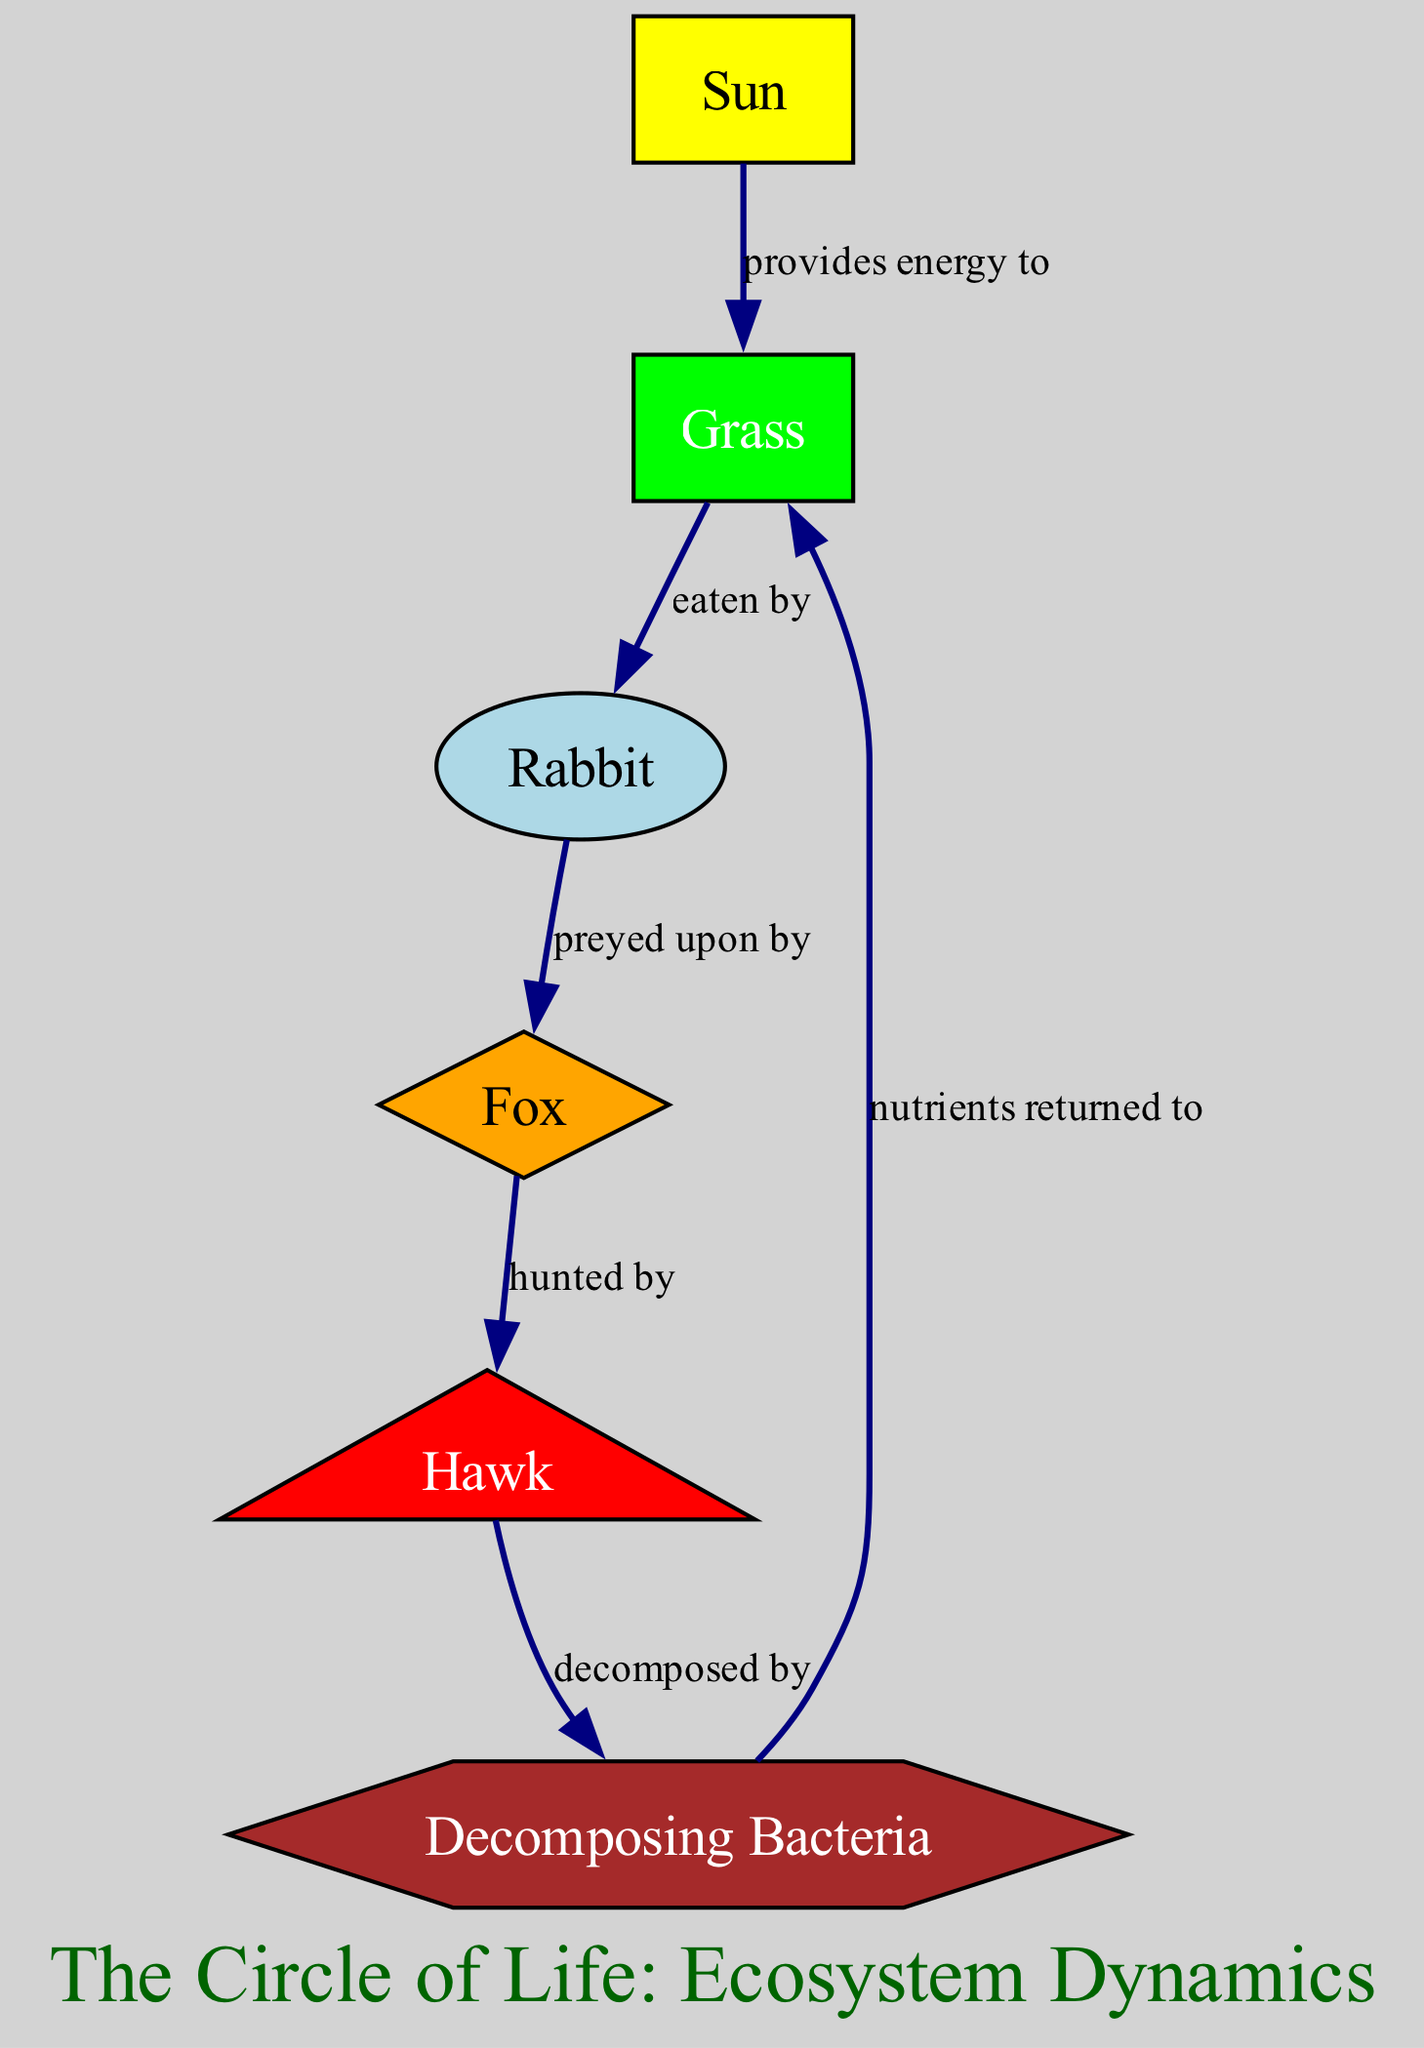What is the total number of nodes in the diagram? The diagram has six nodes listed: Sun, Grass, Rabbit, Fox, Hawk, and Bacteria. Therefore, counting them gives a total of six nodes.
Answer: 6 What type of node is a Rabbit? The Rabbit node is classified as a primary consumer.
Answer: primary consumer Which node is decomposed by the Hawk? According to the diagram, the Hawk is decomposed by Bacteria.
Answer: Bacteria What relationship exists between Grass and Rabbit? The Grass node has an edge labeled "eaten by," indicating that Rabbits eat Grass, establishing a predator-prey relationship.
Answer: eaten by How many edges are there in the diagram? There are five edges represented, showing the different relationships between the nodes in the food chain.
Answer: 5 Which node serves as the energy source? The Sun is identified as the primary energy source for the entire ecosystem, providing energy to Grass.
Answer: Sun What is the connection between Fox and Hawk? The Fox is preyed upon by the Hawk, indicated by the directed edge labeled "hunted by."
Answer: hunted by What nutrient cycle is present in the food chain? The nutrients are returned to Grass by the decomposing Bacteria after the Hawk is decomposed, completing the cycle.
Answer: nutrients returned to Which node is at the top of the food chain? The Hawk is represented as the apex predator in this food chain, being the top consumer.
Answer: Hawk How does energy flow from the Sun to the Rabbit? Energy flows from the Sun to Grass, which is then eaten by Rabbits, establishing the flow of energy through the food chain.
Answer: provides energy to 